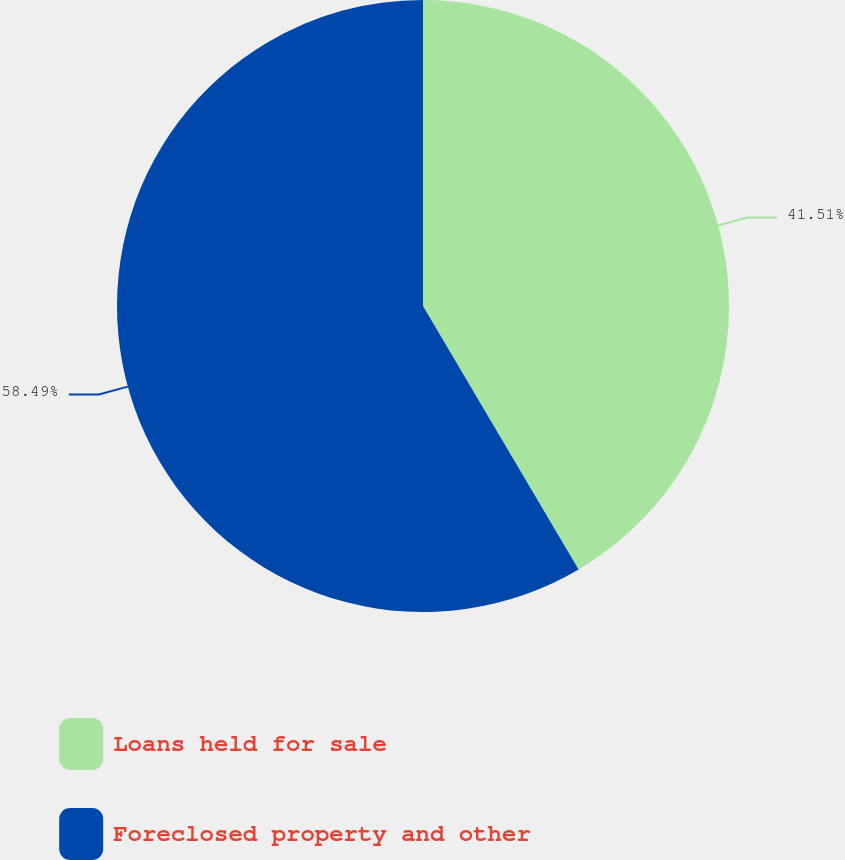<chart> <loc_0><loc_0><loc_500><loc_500><pie_chart><fcel>Loans held for sale<fcel>Foreclosed property and other<nl><fcel>41.51%<fcel>58.49%<nl></chart> 